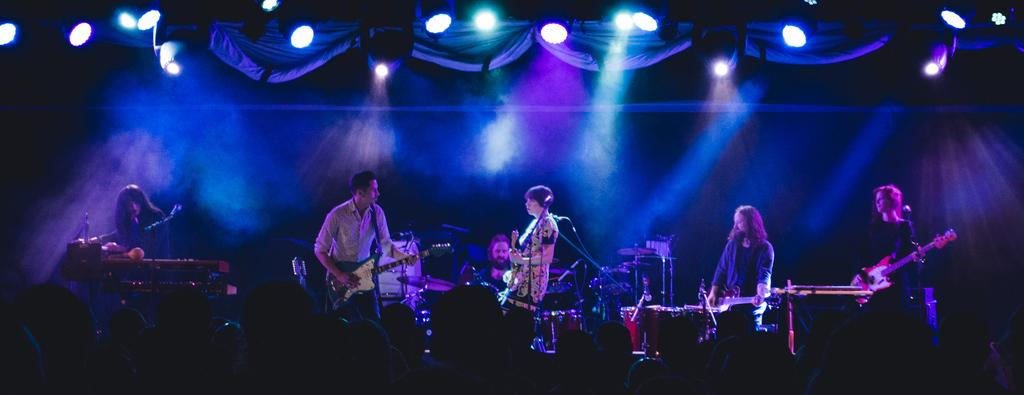What is happening in the image? There is a group of people in the image, and they are playing musical instruments. Where are the people located in the image? The people are standing on a stage. What object is present in front of the group? There is a microphone in front of the group. What type of prose is being recited by the goose in the image? There is no goose present in the image, and therefore no prose being recited. 